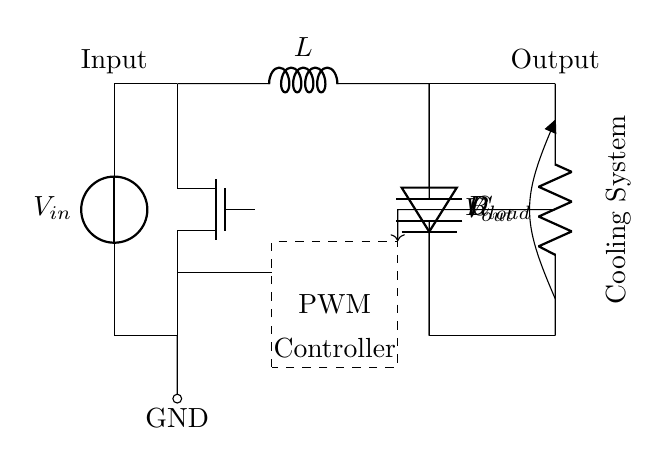What is the input voltage indicated in the circuit? The circuit diagram does not specify a numeric value for the input voltage, but it does label it as V in. Therefore, it is simply represented as a variable.
Answer: V in What type of switch is used in this circuit? The circuit diagram illustrates that a Tnmos, which is a type of MOSFET, is employed as the switch component for controlling the power flow.
Answer: Tnmos How many main components are used in this switched-mode power supply circuit? The visible major components in the diagram include the voltage source, MOSFET, PWM controller, inductor, diode, capacitor, and load resistor, totaling seven main components.
Answer: Seven What is the function of the PWM controller in this circuit? The PWM controller modulates the power supplied to the load by adjusting the duty cycle, hence controlling the output voltage and efficiency of the switching power supply.
Answer: Modulates power What is the role of the inductor in the switched-mode power supply? The inductor stores energy when the switch (MOSFET) is on and releases it to the output when the switch is off, which is essential for energy conversion and maintaining a steady output voltage.
Answer: Stores energy In which direction does the current flow through the diode? The standard operation of a diode allows current to flow from the anode to the cathode, which in this circuit is oriented to permit current flow from the inductor to the capacitor and load.
Answer: Anode to cathode What type of load does this circuit supply? The circuit provides power to a load resistor, which is connected parallel to a capacitor, indicating it supplies energy to a resistive load.
Answer: Resistive load 